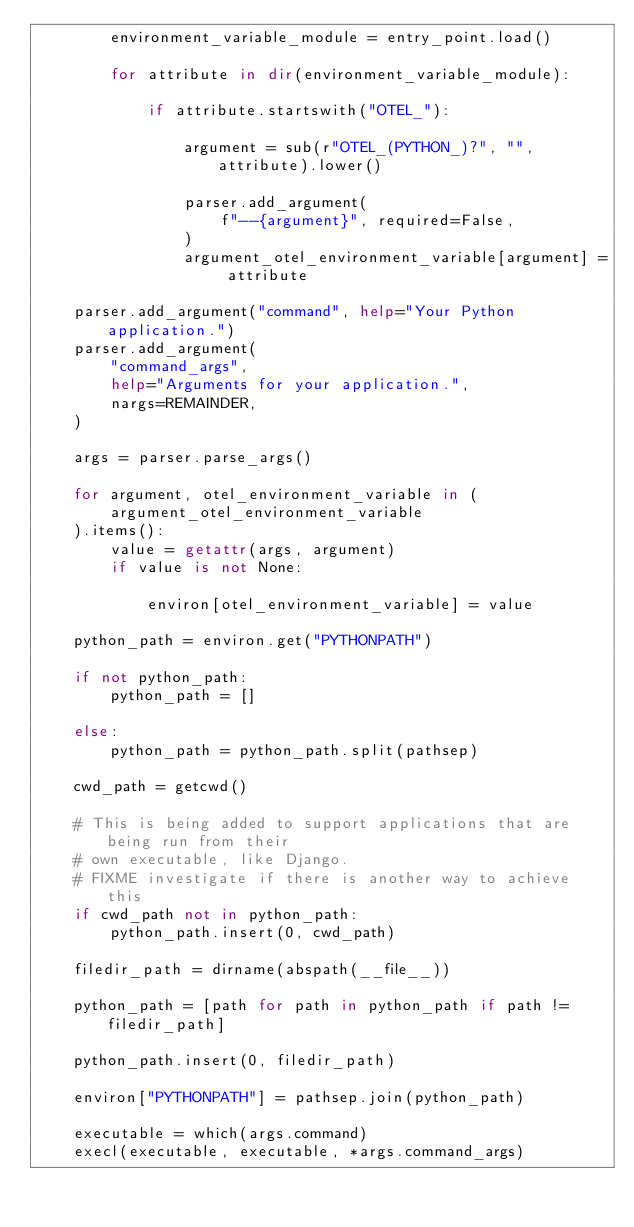Convert code to text. <code><loc_0><loc_0><loc_500><loc_500><_Python_>        environment_variable_module = entry_point.load()

        for attribute in dir(environment_variable_module):

            if attribute.startswith("OTEL_"):

                argument = sub(r"OTEL_(PYTHON_)?", "", attribute).lower()

                parser.add_argument(
                    f"--{argument}", required=False,
                )
                argument_otel_environment_variable[argument] = attribute

    parser.add_argument("command", help="Your Python application.")
    parser.add_argument(
        "command_args",
        help="Arguments for your application.",
        nargs=REMAINDER,
    )

    args = parser.parse_args()

    for argument, otel_environment_variable in (
        argument_otel_environment_variable
    ).items():
        value = getattr(args, argument)
        if value is not None:

            environ[otel_environment_variable] = value

    python_path = environ.get("PYTHONPATH")

    if not python_path:
        python_path = []

    else:
        python_path = python_path.split(pathsep)

    cwd_path = getcwd()

    # This is being added to support applications that are being run from their
    # own executable, like Django.
    # FIXME investigate if there is another way to achieve this
    if cwd_path not in python_path:
        python_path.insert(0, cwd_path)

    filedir_path = dirname(abspath(__file__))

    python_path = [path for path in python_path if path != filedir_path]

    python_path.insert(0, filedir_path)

    environ["PYTHONPATH"] = pathsep.join(python_path)

    executable = which(args.command)
    execl(executable, executable, *args.command_args)
</code> 